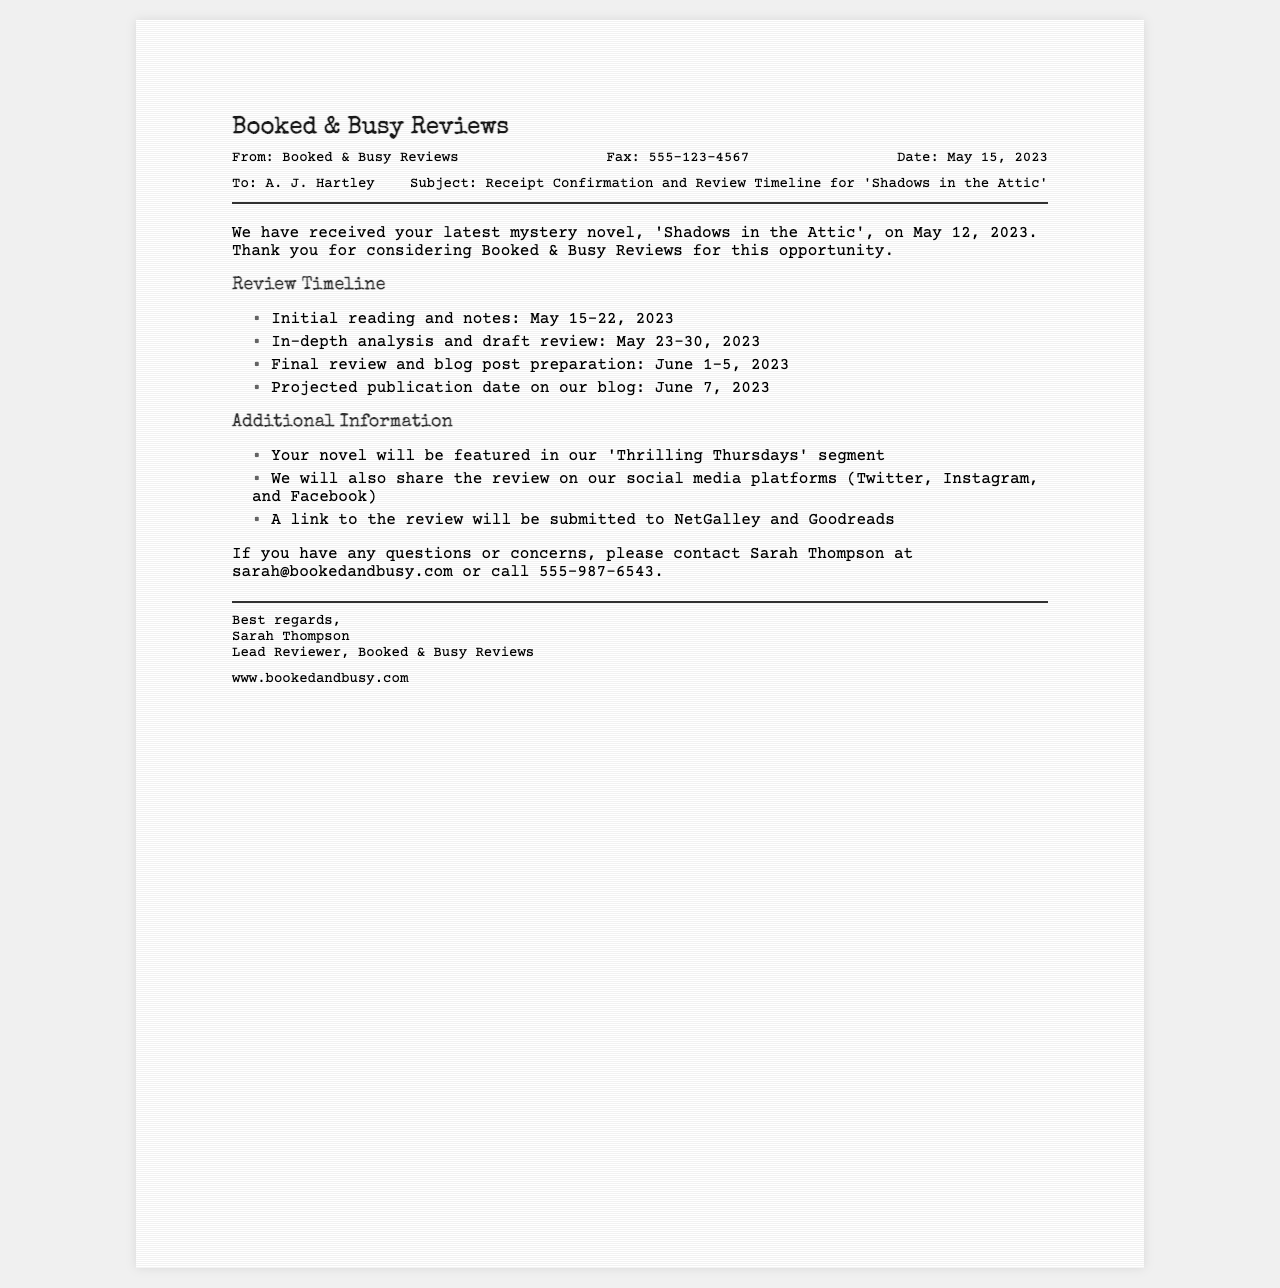What is the name of the novel reviewed? The novel being reviewed is stated in the document.
Answer: 'Shadows in the Attic' Who is the lead reviewer? The document lists the name of the individual who is the lead reviewer.
Answer: Sarah Thompson What date was the novel received? The document specifies the date the novel was confirmed as received.
Answer: May 12, 2023 What is the projected publication date for the review? The document mentions the date when the review is projected to be published.
Answer: June 7, 2023 What segment will feature the novel? The document includes information about where the novel will be featured.
Answer: 'Thrilling Thursdays' How many days are allocated for initial reading and notes? The document provides a time range for the initial reading phase.
Answer: 8 days What is the fax number listed in the document? The document includes a fax number for communication.
Answer: 555-123-4567 What email address should questions be directed to? The document specifies an email address for inquiries.
Answer: sarah@bookedandbusy.com When will the in-depth analysis and draft review occur? The document details the time frame for the analysis and drafting stage.
Answer: May 23-30, 2023 